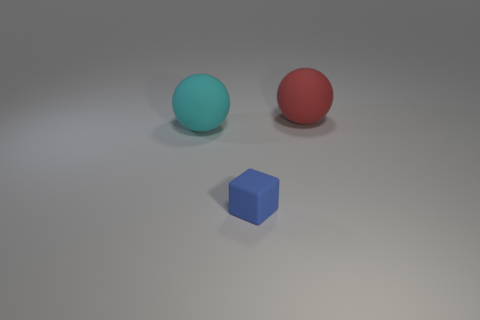Add 1 blue things. How many objects exist? 4 Subtract 2 balls. How many balls are left? 0 Subtract all blocks. How many objects are left? 2 Add 2 red rubber spheres. How many red rubber spheres exist? 3 Subtract 0 yellow blocks. How many objects are left? 3 Subtract all gray balls. Subtract all yellow cubes. How many balls are left? 2 Subtract all cyan cylinders. How many brown spheres are left? 0 Subtract all red metallic spheres. Subtract all spheres. How many objects are left? 1 Add 3 cyan balls. How many cyan balls are left? 4 